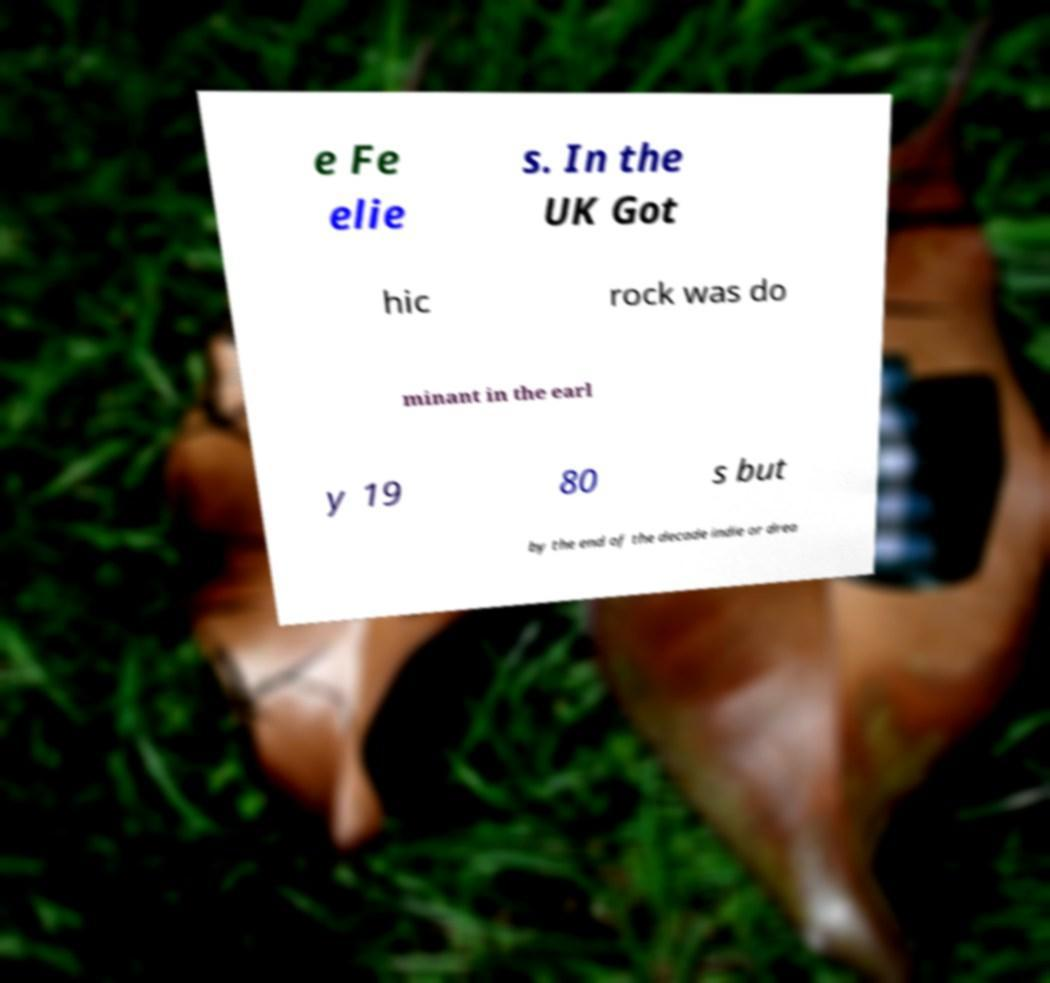Could you assist in decoding the text presented in this image and type it out clearly? e Fe elie s. In the UK Got hic rock was do minant in the earl y 19 80 s but by the end of the decade indie or drea 